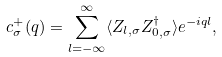Convert formula to latex. <formula><loc_0><loc_0><loc_500><loc_500>c ^ { + } _ { \sigma } ( q ) = \sum _ { l = - \infty } ^ { \infty } \langle Z _ { l , \sigma } Z ^ { \dagger } _ { 0 , \sigma } \rangle e ^ { - i q l } ,</formula> 